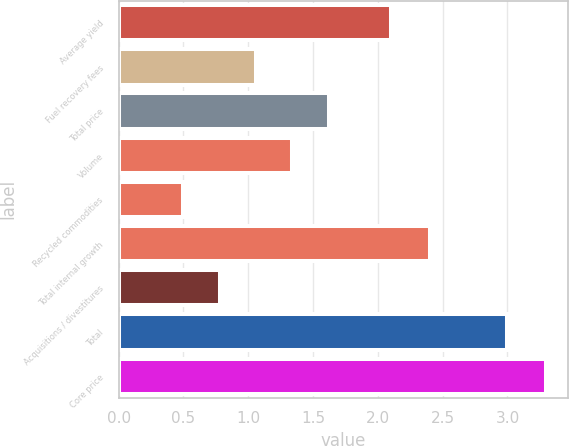Convert chart. <chart><loc_0><loc_0><loc_500><loc_500><bar_chart><fcel>Average yield<fcel>Fuel recovery fees<fcel>Total price<fcel>Volume<fcel>Recycled commodities<fcel>Total internal growth<fcel>Acquisitions / divestitures<fcel>Total<fcel>Core price<nl><fcel>2.1<fcel>1.06<fcel>1.62<fcel>1.34<fcel>0.5<fcel>2.4<fcel>0.78<fcel>3<fcel>3.3<nl></chart> 